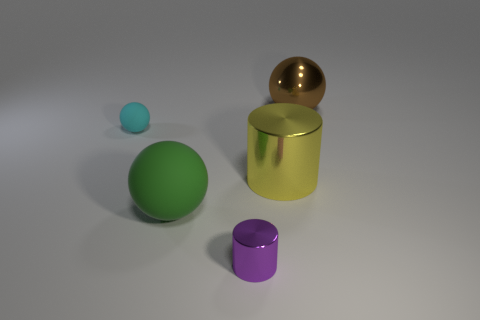Add 2 tiny red blocks. How many objects exist? 7 Subtract all cylinders. How many objects are left? 3 Subtract 0 green blocks. How many objects are left? 5 Subtract all metal balls. Subtract all small cyan matte balls. How many objects are left? 3 Add 4 green balls. How many green balls are left? 5 Add 2 large cyan metal cubes. How many large cyan metal cubes exist? 2 